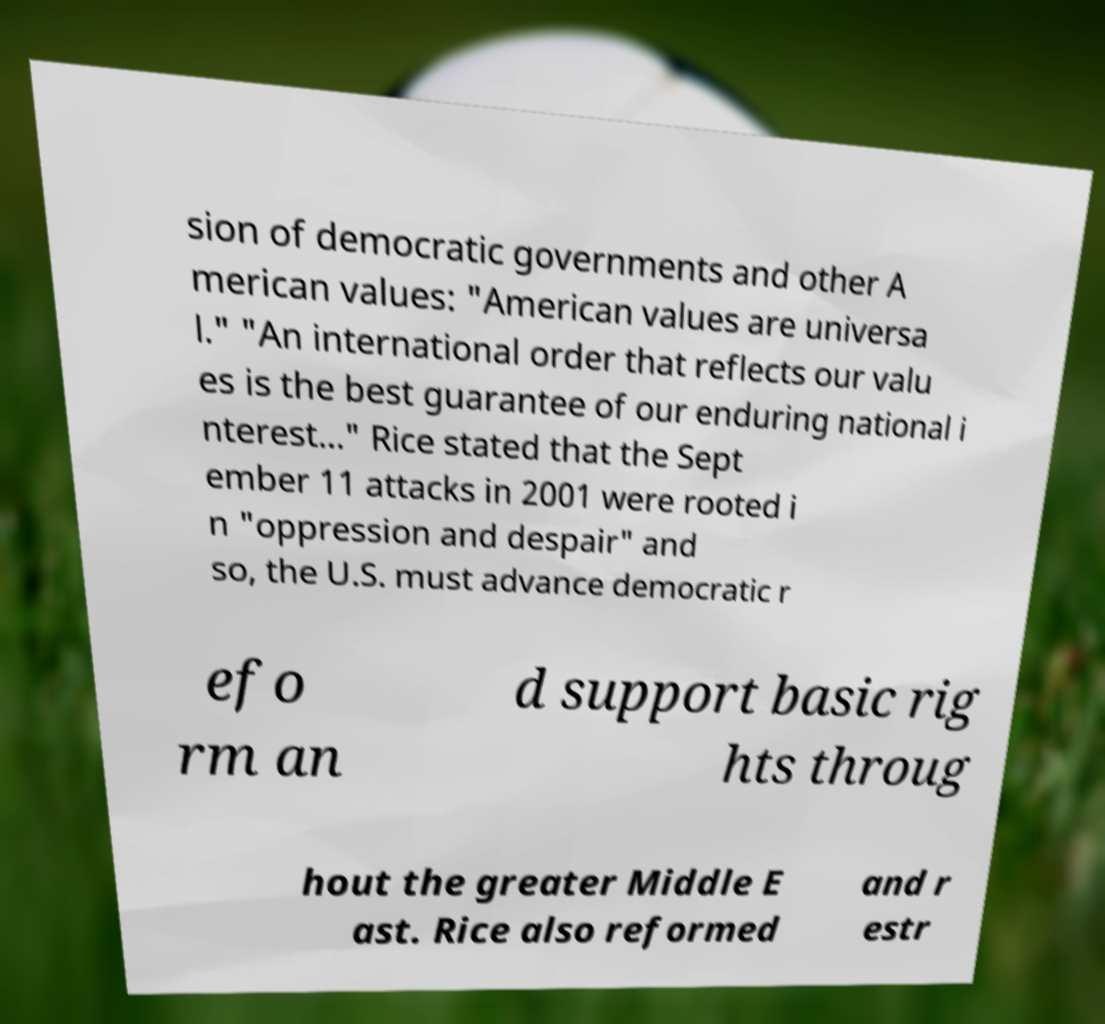What messages or text are displayed in this image? I need them in a readable, typed format. sion of democratic governments and other A merican values: "American values are universa l." "An international order that reflects our valu es is the best guarantee of our enduring national i nterest..." Rice stated that the Sept ember 11 attacks in 2001 were rooted i n "oppression and despair" and so, the U.S. must advance democratic r efo rm an d support basic rig hts throug hout the greater Middle E ast. Rice also reformed and r estr 